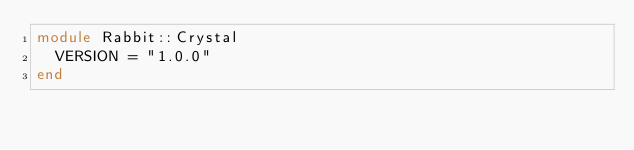<code> <loc_0><loc_0><loc_500><loc_500><_Crystal_>module Rabbit::Crystal
  VERSION = "1.0.0"
end
</code> 